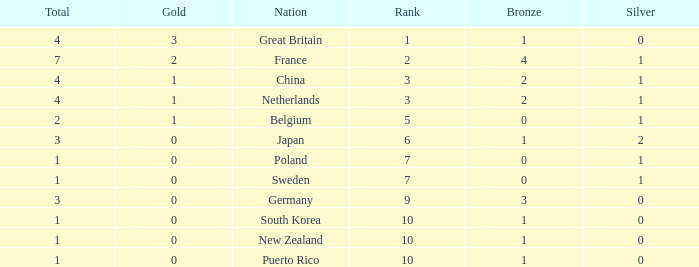What is the rank with 0 bronze? None. 